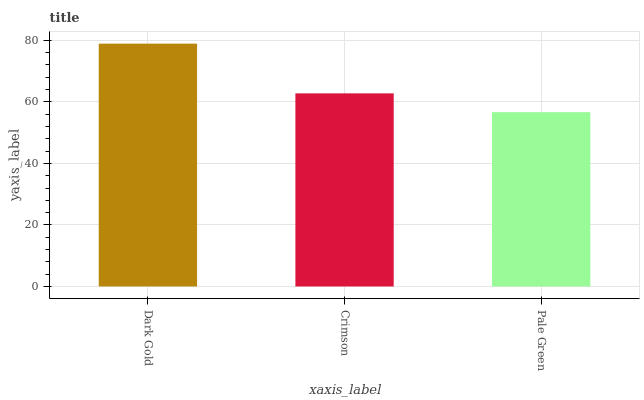Is Pale Green the minimum?
Answer yes or no. Yes. Is Dark Gold the maximum?
Answer yes or no. Yes. Is Crimson the minimum?
Answer yes or no. No. Is Crimson the maximum?
Answer yes or no. No. Is Dark Gold greater than Crimson?
Answer yes or no. Yes. Is Crimson less than Dark Gold?
Answer yes or no. Yes. Is Crimson greater than Dark Gold?
Answer yes or no. No. Is Dark Gold less than Crimson?
Answer yes or no. No. Is Crimson the high median?
Answer yes or no. Yes. Is Crimson the low median?
Answer yes or no. Yes. Is Dark Gold the high median?
Answer yes or no. No. Is Pale Green the low median?
Answer yes or no. No. 